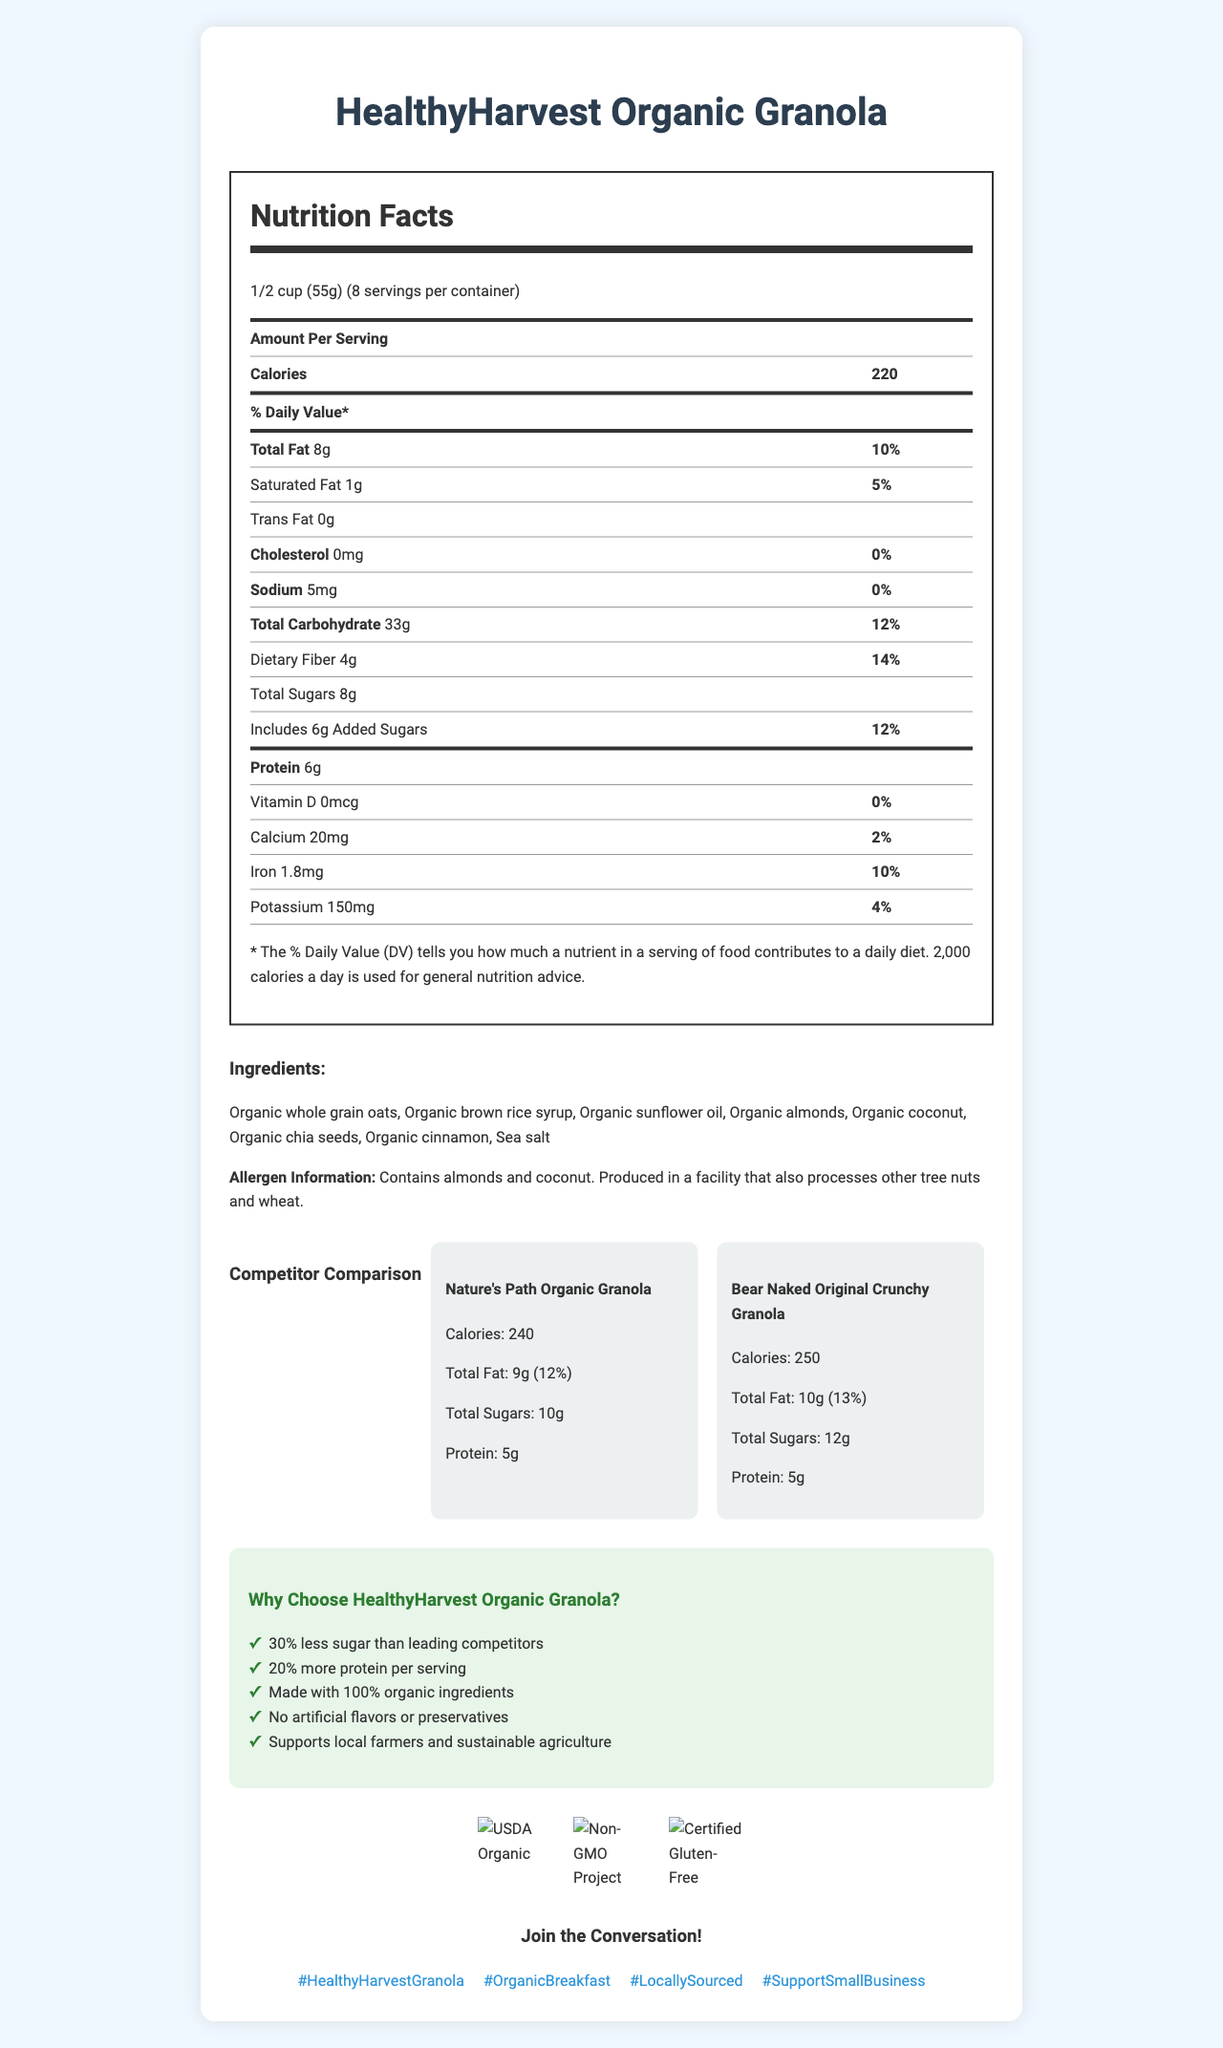what's the serving size of HealthyHarvest Organic Granola? The serving size is clearly stated at the beginning of the document under the Nutrition Facts section.
Answer: 1/2 cup (55g) how many calories per serving does HealthyHarvest Organic Granola have? This information is highlighted under the main title ‘Amount Per Serving’ within the Nutrition Facts section.
Answer: 220 calories how much protein does HealthyHarvest Organic Granola contain per serving? The document lists the protein content of HealthyHarvest Organic Granola as 6 grams per serving.
Answer: 6 grams what are the main ingredients in HealthyHarvest Organic Granola? The ingredients are clearly listed in the section titled "Ingredients".
Answer: Organic whole grain oats, Organic brown rice syrup, Organic sunflower oil, Organic almonds, Organic coconut, Organic chia seeds, Organic cinnamon, Sea salt which competitor has more total fat per serving? The document indicates Bear Naked Original Crunchy Granola has 10 grams of total fat per serving, compared to Nature's Path Organic Granola with 9 grams.
Answer: Bear Naked Original Crunchy Granola which product offers the highest daily value percentage for total fat? A. HealthyHarvest Organic Granola B. Nature's Path Organic Granola C. Bear Naked Original Crunchy Granola Bear Naked Original Crunchy Granola has the highest daily value percentage of total fat at 13%.
Answer: C. Bear Naked Original Crunchy Granola how many grams of added sugars are in HealthyHarvest Organic Granola? The document specifies that HealthyHarvest Organic Granola includes 6 grams of added sugars.
Answer: 6 grams does HealthyHarvest Organic Granola contain any trans fat? The Nutrition Facts section mentions that HealthyHarvest Organic Granola has 0 grams of trans fat.
Answer: No which certification ensures that HealthyHarvest Organic Granola is not genetically modified? A. USDA Organic B. Non-GMO Project Verified C. Certified Gluten-Free The document lists "Non-GMO Project Verified" as one of the certifications, ensuring it is not genetically modified.
Answer: B. Non-GMO Project Verified is there any cholesterol in HealthyHarvest Organic Granola? The Nutrition Facts section shows that HealthyHarvest Organic Granola has 0 milligrams of cholesterol.
Answer: No provide a summary of the main benefits of choosing HealthyHarvest Organic Granola. The Marketing Highlights section outlines these benefits, showcasing why HealthyHarvest Organic Granola is a healthier and more sustainable choice compared to its competitors.
Answer: HealthyHarvest Organic Granola offers several benefits including having 30% less sugar than leading competitors, 20% more protein per serving, being made with 100% organic ingredients, not containing any artificial flavors or preservatives, and supporting local farmers and sustainable agriculture. It is also certified USDA Organic, Non-GMO Project Verified, and Certified Gluten-Free. how many grams of total sugars are in Bear Naked Original Crunchy Granola? The document specifies that Bear Naked Original Crunchy Granola has 12 grams of total sugars per serving.
Answer: 12 grams what is the % Daily Value for calcium in HealthyHarvest Organic Granola? The Nutrition Facts section specifies that the % Daily Value for calcium in HealthyHarvest Organic Granola is 2%.
Answer: 2% compare the calories per serving of HealthyHarvest Organic Granola with both competitors. This comparison can be found under the Competitor Comparison section, where each product’s calories per serving are listed.
Answer: HealthyHarvest Organic Granola has 220 calories per serving, Nature's Path Organic Granola has 240 calories, and Bear Naked Original Crunchy Granola has 250 calories how does HealthyHarvest Organic Granola support local farmers? The document states that the product supports local farmers, but it does not detail how this support is provided.
Answer: Not enough information 